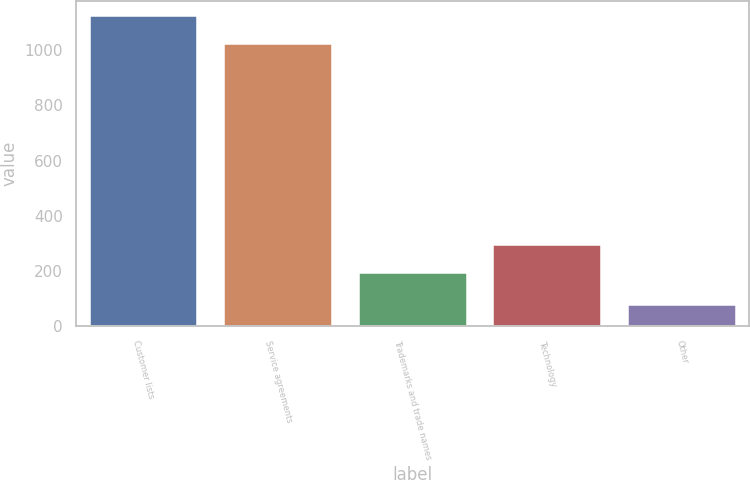Convert chart. <chart><loc_0><loc_0><loc_500><loc_500><bar_chart><fcel>Customer lists<fcel>Service agreements<fcel>Trademarks and trade names<fcel>Technology<fcel>Other<nl><fcel>1122.5<fcel>1022<fcel>192<fcel>292.5<fcel>76<nl></chart> 